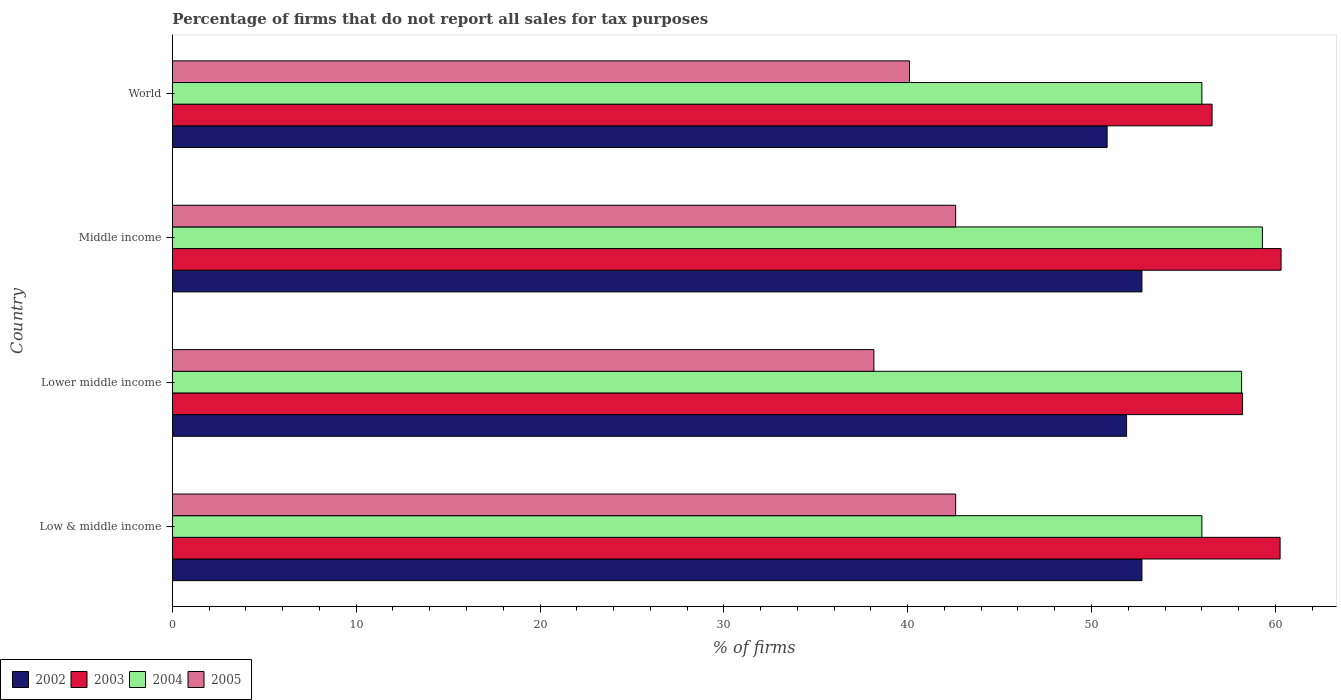How many groups of bars are there?
Provide a succinct answer. 4. How many bars are there on the 1st tick from the top?
Offer a terse response. 4. What is the label of the 2nd group of bars from the top?
Offer a terse response. Middle income. In how many cases, is the number of bars for a given country not equal to the number of legend labels?
Your answer should be very brief. 0. What is the percentage of firms that do not report all sales for tax purposes in 2004 in Lower middle income?
Keep it short and to the point. 58.16. Across all countries, what is the maximum percentage of firms that do not report all sales for tax purposes in 2003?
Provide a short and direct response. 60.31. Across all countries, what is the minimum percentage of firms that do not report all sales for tax purposes in 2004?
Ensure brevity in your answer.  56.01. What is the total percentage of firms that do not report all sales for tax purposes in 2004 in the graph?
Make the answer very short. 229.47. What is the difference between the percentage of firms that do not report all sales for tax purposes in 2002 in Lower middle income and the percentage of firms that do not report all sales for tax purposes in 2004 in Middle income?
Provide a short and direct response. -7.39. What is the average percentage of firms that do not report all sales for tax purposes in 2002 per country?
Your response must be concise. 52.06. What is the difference between the percentage of firms that do not report all sales for tax purposes in 2003 and percentage of firms that do not report all sales for tax purposes in 2004 in Middle income?
Offer a very short reply. 1.02. In how many countries, is the percentage of firms that do not report all sales for tax purposes in 2005 greater than 38 %?
Provide a short and direct response. 4. What is the ratio of the percentage of firms that do not report all sales for tax purposes in 2004 in Low & middle income to that in Middle income?
Keep it short and to the point. 0.94. Is the percentage of firms that do not report all sales for tax purposes in 2003 in Low & middle income less than that in Middle income?
Your answer should be very brief. Yes. What is the difference between the highest and the lowest percentage of firms that do not report all sales for tax purposes in 2004?
Offer a very short reply. 3.29. Is the sum of the percentage of firms that do not report all sales for tax purposes in 2004 in Low & middle income and Middle income greater than the maximum percentage of firms that do not report all sales for tax purposes in 2003 across all countries?
Offer a terse response. Yes. What does the 2nd bar from the bottom in World represents?
Your answer should be very brief. 2003. Is it the case that in every country, the sum of the percentage of firms that do not report all sales for tax purposes in 2003 and percentage of firms that do not report all sales for tax purposes in 2002 is greater than the percentage of firms that do not report all sales for tax purposes in 2005?
Give a very brief answer. Yes. How many bars are there?
Provide a succinct answer. 16. How many countries are there in the graph?
Keep it short and to the point. 4. Does the graph contain grids?
Offer a very short reply. No. Where does the legend appear in the graph?
Provide a succinct answer. Bottom left. How many legend labels are there?
Offer a terse response. 4. How are the legend labels stacked?
Provide a succinct answer. Horizontal. What is the title of the graph?
Make the answer very short. Percentage of firms that do not report all sales for tax purposes. What is the label or title of the X-axis?
Your response must be concise. % of firms. What is the % of firms of 2002 in Low & middle income?
Your answer should be very brief. 52.75. What is the % of firms in 2003 in Low & middle income?
Your answer should be very brief. 60.26. What is the % of firms of 2004 in Low & middle income?
Keep it short and to the point. 56.01. What is the % of firms of 2005 in Low & middle income?
Offer a terse response. 42.61. What is the % of firms in 2002 in Lower middle income?
Offer a very short reply. 51.91. What is the % of firms of 2003 in Lower middle income?
Your answer should be compact. 58.22. What is the % of firms in 2004 in Lower middle income?
Your answer should be very brief. 58.16. What is the % of firms of 2005 in Lower middle income?
Provide a short and direct response. 38.16. What is the % of firms in 2002 in Middle income?
Your response must be concise. 52.75. What is the % of firms of 2003 in Middle income?
Your answer should be very brief. 60.31. What is the % of firms in 2004 in Middle income?
Offer a very short reply. 59.3. What is the % of firms of 2005 in Middle income?
Provide a short and direct response. 42.61. What is the % of firms in 2002 in World?
Keep it short and to the point. 50.85. What is the % of firms of 2003 in World?
Offer a terse response. 56.56. What is the % of firms in 2004 in World?
Keep it short and to the point. 56.01. What is the % of firms of 2005 in World?
Make the answer very short. 40.1. Across all countries, what is the maximum % of firms of 2002?
Provide a succinct answer. 52.75. Across all countries, what is the maximum % of firms of 2003?
Ensure brevity in your answer.  60.31. Across all countries, what is the maximum % of firms in 2004?
Keep it short and to the point. 59.3. Across all countries, what is the maximum % of firms in 2005?
Your answer should be very brief. 42.61. Across all countries, what is the minimum % of firms of 2002?
Provide a succinct answer. 50.85. Across all countries, what is the minimum % of firms in 2003?
Provide a short and direct response. 56.56. Across all countries, what is the minimum % of firms in 2004?
Offer a terse response. 56.01. Across all countries, what is the minimum % of firms of 2005?
Offer a very short reply. 38.16. What is the total % of firms in 2002 in the graph?
Provide a succinct answer. 208.25. What is the total % of firms in 2003 in the graph?
Your response must be concise. 235.35. What is the total % of firms of 2004 in the graph?
Keep it short and to the point. 229.47. What is the total % of firms in 2005 in the graph?
Your answer should be very brief. 163.48. What is the difference between the % of firms of 2002 in Low & middle income and that in Lower middle income?
Provide a short and direct response. 0.84. What is the difference between the % of firms in 2003 in Low & middle income and that in Lower middle income?
Your answer should be very brief. 2.04. What is the difference between the % of firms in 2004 in Low & middle income and that in Lower middle income?
Make the answer very short. -2.16. What is the difference between the % of firms of 2005 in Low & middle income and that in Lower middle income?
Your answer should be very brief. 4.45. What is the difference between the % of firms in 2002 in Low & middle income and that in Middle income?
Provide a short and direct response. 0. What is the difference between the % of firms in 2003 in Low & middle income and that in Middle income?
Provide a succinct answer. -0.05. What is the difference between the % of firms of 2004 in Low & middle income and that in Middle income?
Your answer should be very brief. -3.29. What is the difference between the % of firms of 2005 in Low & middle income and that in Middle income?
Your answer should be very brief. 0. What is the difference between the % of firms of 2002 in Low & middle income and that in World?
Your response must be concise. 1.89. What is the difference between the % of firms in 2003 in Low & middle income and that in World?
Your answer should be very brief. 3.7. What is the difference between the % of firms in 2005 in Low & middle income and that in World?
Your answer should be compact. 2.51. What is the difference between the % of firms in 2002 in Lower middle income and that in Middle income?
Provide a short and direct response. -0.84. What is the difference between the % of firms of 2003 in Lower middle income and that in Middle income?
Keep it short and to the point. -2.09. What is the difference between the % of firms of 2004 in Lower middle income and that in Middle income?
Provide a short and direct response. -1.13. What is the difference between the % of firms in 2005 in Lower middle income and that in Middle income?
Ensure brevity in your answer.  -4.45. What is the difference between the % of firms in 2002 in Lower middle income and that in World?
Your answer should be very brief. 1.06. What is the difference between the % of firms in 2003 in Lower middle income and that in World?
Provide a short and direct response. 1.66. What is the difference between the % of firms in 2004 in Lower middle income and that in World?
Provide a succinct answer. 2.16. What is the difference between the % of firms in 2005 in Lower middle income and that in World?
Your answer should be very brief. -1.94. What is the difference between the % of firms of 2002 in Middle income and that in World?
Make the answer very short. 1.89. What is the difference between the % of firms of 2003 in Middle income and that in World?
Provide a succinct answer. 3.75. What is the difference between the % of firms of 2004 in Middle income and that in World?
Offer a very short reply. 3.29. What is the difference between the % of firms in 2005 in Middle income and that in World?
Offer a terse response. 2.51. What is the difference between the % of firms of 2002 in Low & middle income and the % of firms of 2003 in Lower middle income?
Your answer should be very brief. -5.47. What is the difference between the % of firms of 2002 in Low & middle income and the % of firms of 2004 in Lower middle income?
Your answer should be very brief. -5.42. What is the difference between the % of firms of 2002 in Low & middle income and the % of firms of 2005 in Lower middle income?
Keep it short and to the point. 14.58. What is the difference between the % of firms of 2003 in Low & middle income and the % of firms of 2004 in Lower middle income?
Your response must be concise. 2.1. What is the difference between the % of firms in 2003 in Low & middle income and the % of firms in 2005 in Lower middle income?
Offer a terse response. 22.1. What is the difference between the % of firms of 2004 in Low & middle income and the % of firms of 2005 in Lower middle income?
Keep it short and to the point. 17.84. What is the difference between the % of firms of 2002 in Low & middle income and the % of firms of 2003 in Middle income?
Your answer should be compact. -7.57. What is the difference between the % of firms of 2002 in Low & middle income and the % of firms of 2004 in Middle income?
Keep it short and to the point. -6.55. What is the difference between the % of firms of 2002 in Low & middle income and the % of firms of 2005 in Middle income?
Offer a terse response. 10.13. What is the difference between the % of firms in 2003 in Low & middle income and the % of firms in 2005 in Middle income?
Give a very brief answer. 17.65. What is the difference between the % of firms of 2004 in Low & middle income and the % of firms of 2005 in Middle income?
Give a very brief answer. 13.39. What is the difference between the % of firms of 2002 in Low & middle income and the % of firms of 2003 in World?
Your response must be concise. -3.81. What is the difference between the % of firms of 2002 in Low & middle income and the % of firms of 2004 in World?
Provide a short and direct response. -3.26. What is the difference between the % of firms in 2002 in Low & middle income and the % of firms in 2005 in World?
Make the answer very short. 12.65. What is the difference between the % of firms of 2003 in Low & middle income and the % of firms of 2004 in World?
Ensure brevity in your answer.  4.25. What is the difference between the % of firms of 2003 in Low & middle income and the % of firms of 2005 in World?
Offer a very short reply. 20.16. What is the difference between the % of firms of 2004 in Low & middle income and the % of firms of 2005 in World?
Offer a terse response. 15.91. What is the difference between the % of firms of 2002 in Lower middle income and the % of firms of 2003 in Middle income?
Offer a terse response. -8.4. What is the difference between the % of firms in 2002 in Lower middle income and the % of firms in 2004 in Middle income?
Provide a short and direct response. -7.39. What is the difference between the % of firms of 2002 in Lower middle income and the % of firms of 2005 in Middle income?
Your answer should be compact. 9.3. What is the difference between the % of firms of 2003 in Lower middle income and the % of firms of 2004 in Middle income?
Keep it short and to the point. -1.08. What is the difference between the % of firms in 2003 in Lower middle income and the % of firms in 2005 in Middle income?
Your answer should be very brief. 15.61. What is the difference between the % of firms in 2004 in Lower middle income and the % of firms in 2005 in Middle income?
Ensure brevity in your answer.  15.55. What is the difference between the % of firms in 2002 in Lower middle income and the % of firms in 2003 in World?
Offer a terse response. -4.65. What is the difference between the % of firms of 2002 in Lower middle income and the % of firms of 2004 in World?
Provide a succinct answer. -4.1. What is the difference between the % of firms in 2002 in Lower middle income and the % of firms in 2005 in World?
Ensure brevity in your answer.  11.81. What is the difference between the % of firms of 2003 in Lower middle income and the % of firms of 2004 in World?
Offer a very short reply. 2.21. What is the difference between the % of firms in 2003 in Lower middle income and the % of firms in 2005 in World?
Your response must be concise. 18.12. What is the difference between the % of firms of 2004 in Lower middle income and the % of firms of 2005 in World?
Offer a very short reply. 18.07. What is the difference between the % of firms in 2002 in Middle income and the % of firms in 2003 in World?
Give a very brief answer. -3.81. What is the difference between the % of firms in 2002 in Middle income and the % of firms in 2004 in World?
Your answer should be very brief. -3.26. What is the difference between the % of firms of 2002 in Middle income and the % of firms of 2005 in World?
Ensure brevity in your answer.  12.65. What is the difference between the % of firms in 2003 in Middle income and the % of firms in 2004 in World?
Your response must be concise. 4.31. What is the difference between the % of firms in 2003 in Middle income and the % of firms in 2005 in World?
Keep it short and to the point. 20.21. What is the difference between the % of firms of 2004 in Middle income and the % of firms of 2005 in World?
Provide a succinct answer. 19.2. What is the average % of firms of 2002 per country?
Your answer should be compact. 52.06. What is the average % of firms of 2003 per country?
Your answer should be very brief. 58.84. What is the average % of firms of 2004 per country?
Your answer should be compact. 57.37. What is the average % of firms in 2005 per country?
Offer a terse response. 40.87. What is the difference between the % of firms in 2002 and % of firms in 2003 in Low & middle income?
Your answer should be compact. -7.51. What is the difference between the % of firms of 2002 and % of firms of 2004 in Low & middle income?
Provide a succinct answer. -3.26. What is the difference between the % of firms in 2002 and % of firms in 2005 in Low & middle income?
Your response must be concise. 10.13. What is the difference between the % of firms of 2003 and % of firms of 2004 in Low & middle income?
Give a very brief answer. 4.25. What is the difference between the % of firms of 2003 and % of firms of 2005 in Low & middle income?
Your answer should be very brief. 17.65. What is the difference between the % of firms of 2004 and % of firms of 2005 in Low & middle income?
Give a very brief answer. 13.39. What is the difference between the % of firms in 2002 and % of firms in 2003 in Lower middle income?
Give a very brief answer. -6.31. What is the difference between the % of firms in 2002 and % of firms in 2004 in Lower middle income?
Offer a terse response. -6.26. What is the difference between the % of firms of 2002 and % of firms of 2005 in Lower middle income?
Your answer should be very brief. 13.75. What is the difference between the % of firms in 2003 and % of firms in 2004 in Lower middle income?
Your response must be concise. 0.05. What is the difference between the % of firms in 2003 and % of firms in 2005 in Lower middle income?
Provide a succinct answer. 20.06. What is the difference between the % of firms of 2004 and % of firms of 2005 in Lower middle income?
Provide a short and direct response. 20. What is the difference between the % of firms of 2002 and % of firms of 2003 in Middle income?
Offer a terse response. -7.57. What is the difference between the % of firms in 2002 and % of firms in 2004 in Middle income?
Give a very brief answer. -6.55. What is the difference between the % of firms of 2002 and % of firms of 2005 in Middle income?
Give a very brief answer. 10.13. What is the difference between the % of firms in 2003 and % of firms in 2004 in Middle income?
Keep it short and to the point. 1.02. What is the difference between the % of firms in 2003 and % of firms in 2005 in Middle income?
Your answer should be very brief. 17.7. What is the difference between the % of firms of 2004 and % of firms of 2005 in Middle income?
Provide a short and direct response. 16.69. What is the difference between the % of firms in 2002 and % of firms in 2003 in World?
Make the answer very short. -5.71. What is the difference between the % of firms of 2002 and % of firms of 2004 in World?
Make the answer very short. -5.15. What is the difference between the % of firms of 2002 and % of firms of 2005 in World?
Give a very brief answer. 10.75. What is the difference between the % of firms in 2003 and % of firms in 2004 in World?
Give a very brief answer. 0.56. What is the difference between the % of firms in 2003 and % of firms in 2005 in World?
Provide a succinct answer. 16.46. What is the difference between the % of firms in 2004 and % of firms in 2005 in World?
Provide a succinct answer. 15.91. What is the ratio of the % of firms in 2002 in Low & middle income to that in Lower middle income?
Offer a very short reply. 1.02. What is the ratio of the % of firms of 2003 in Low & middle income to that in Lower middle income?
Keep it short and to the point. 1.04. What is the ratio of the % of firms of 2004 in Low & middle income to that in Lower middle income?
Provide a short and direct response. 0.96. What is the ratio of the % of firms in 2005 in Low & middle income to that in Lower middle income?
Provide a succinct answer. 1.12. What is the ratio of the % of firms of 2004 in Low & middle income to that in Middle income?
Ensure brevity in your answer.  0.94. What is the ratio of the % of firms in 2005 in Low & middle income to that in Middle income?
Your answer should be compact. 1. What is the ratio of the % of firms in 2002 in Low & middle income to that in World?
Provide a succinct answer. 1.04. What is the ratio of the % of firms of 2003 in Low & middle income to that in World?
Ensure brevity in your answer.  1.07. What is the ratio of the % of firms in 2005 in Low & middle income to that in World?
Ensure brevity in your answer.  1.06. What is the ratio of the % of firms of 2002 in Lower middle income to that in Middle income?
Ensure brevity in your answer.  0.98. What is the ratio of the % of firms of 2003 in Lower middle income to that in Middle income?
Make the answer very short. 0.97. What is the ratio of the % of firms of 2004 in Lower middle income to that in Middle income?
Make the answer very short. 0.98. What is the ratio of the % of firms of 2005 in Lower middle income to that in Middle income?
Offer a very short reply. 0.9. What is the ratio of the % of firms of 2002 in Lower middle income to that in World?
Provide a short and direct response. 1.02. What is the ratio of the % of firms of 2003 in Lower middle income to that in World?
Your response must be concise. 1.03. What is the ratio of the % of firms of 2004 in Lower middle income to that in World?
Keep it short and to the point. 1.04. What is the ratio of the % of firms in 2005 in Lower middle income to that in World?
Your answer should be very brief. 0.95. What is the ratio of the % of firms in 2002 in Middle income to that in World?
Offer a very short reply. 1.04. What is the ratio of the % of firms of 2003 in Middle income to that in World?
Give a very brief answer. 1.07. What is the ratio of the % of firms in 2004 in Middle income to that in World?
Provide a succinct answer. 1.06. What is the ratio of the % of firms of 2005 in Middle income to that in World?
Provide a short and direct response. 1.06. What is the difference between the highest and the second highest % of firms in 2003?
Give a very brief answer. 0.05. What is the difference between the highest and the second highest % of firms of 2004?
Provide a succinct answer. 1.13. What is the difference between the highest and the lowest % of firms of 2002?
Make the answer very short. 1.89. What is the difference between the highest and the lowest % of firms in 2003?
Your response must be concise. 3.75. What is the difference between the highest and the lowest % of firms of 2004?
Provide a succinct answer. 3.29. What is the difference between the highest and the lowest % of firms in 2005?
Keep it short and to the point. 4.45. 